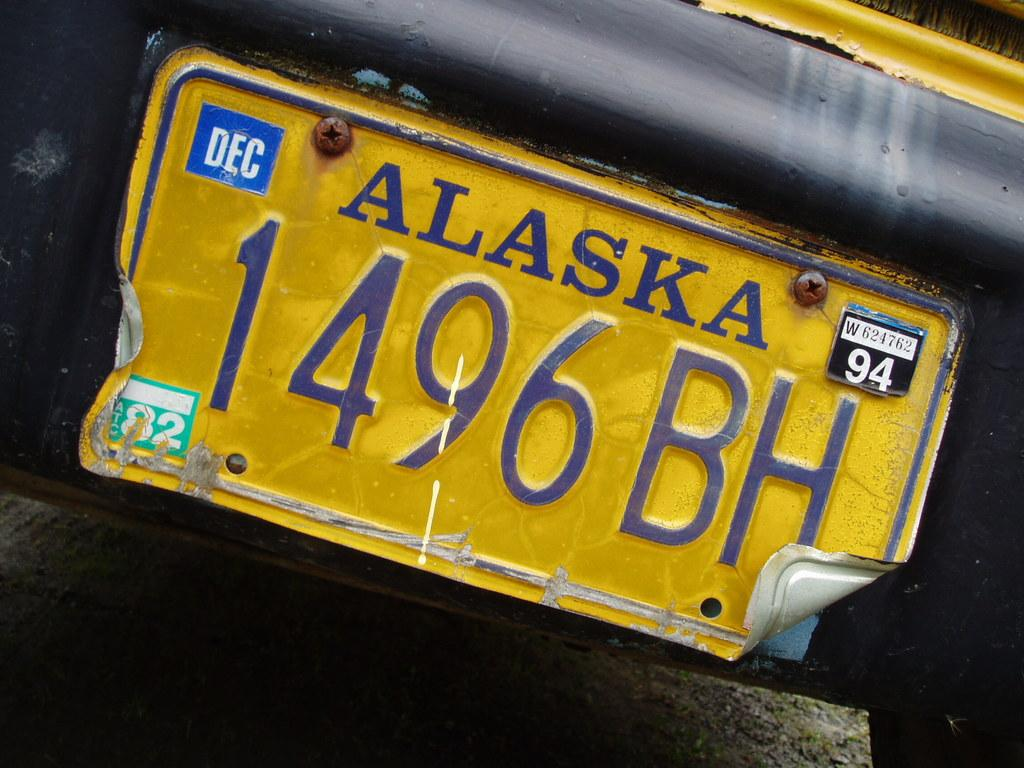Provide a one-sentence caption for the provided image. A yellow Alaska license plate that has 94 in the top right and 1496BH in the middle with a bent lower right corner. 